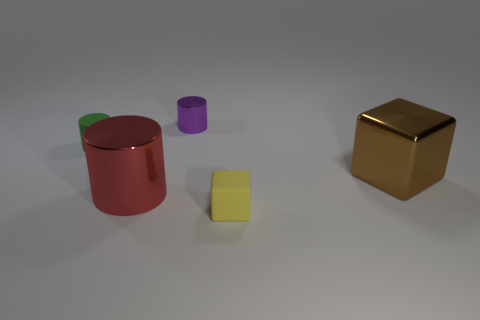What number of things are small shiny cylinders or yellow cubes?
Provide a short and direct response. 2. Does the yellow rubber object have the same shape as the purple metallic thing?
Your answer should be compact. No. What is the material of the tiny green cylinder?
Your answer should be compact. Rubber. How many large objects are to the right of the tiny shiny object and left of the yellow rubber object?
Make the answer very short. 0. Is the red shiny cylinder the same size as the yellow matte thing?
Your answer should be compact. No. Does the yellow rubber block that is in front of the red cylinder have the same size as the small green thing?
Make the answer very short. Yes. The tiny cylinder right of the big red cylinder is what color?
Give a very brief answer. Purple. What number of small green rubber cylinders are there?
Your response must be concise. 1. What is the shape of the large red thing that is the same material as the purple cylinder?
Ensure brevity in your answer.  Cylinder. There is a cube that is to the right of the yellow rubber thing; is it the same color as the object that is in front of the red metal cylinder?
Provide a short and direct response. No. 